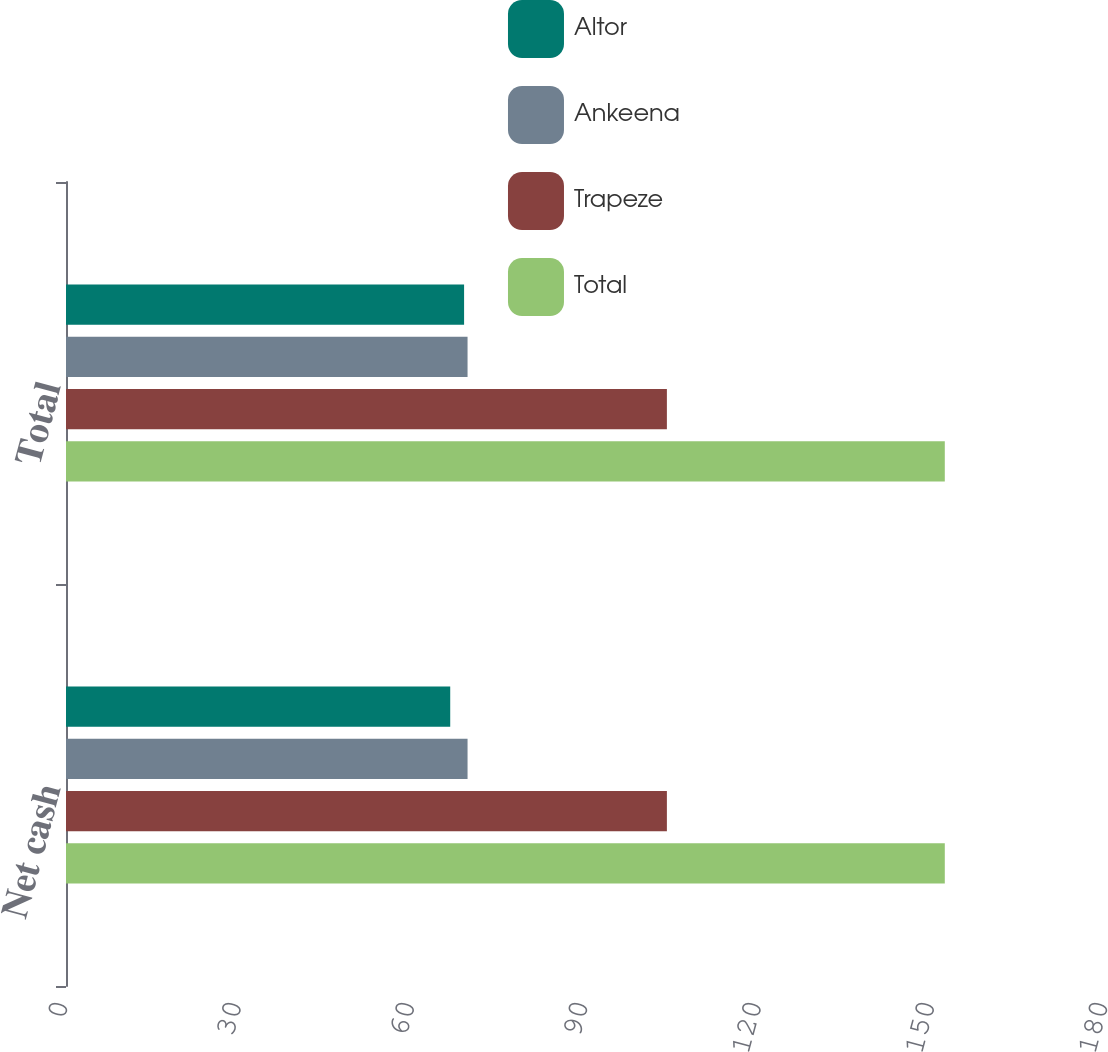<chart> <loc_0><loc_0><loc_500><loc_500><stacked_bar_chart><ecel><fcel>Net cash<fcel>Total<nl><fcel>Altor<fcel>66.5<fcel>68.9<nl><fcel>Ankeena<fcel>69.5<fcel>69.5<nl><fcel>Trapeze<fcel>104<fcel>104<nl><fcel>Total<fcel>152.1<fcel>152.1<nl></chart> 